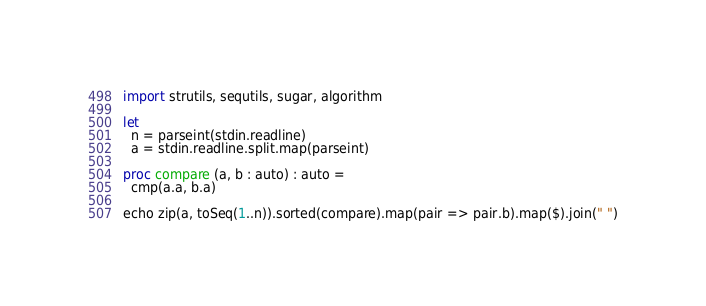Convert code to text. <code><loc_0><loc_0><loc_500><loc_500><_Nim_>import strutils, sequtils, sugar, algorithm

let
  n = parseint(stdin.readline)
  a = stdin.readline.split.map(parseint)

proc compare (a, b : auto) : auto =
  cmp(a.a, b.a)

echo zip(a, toSeq(1..n)).sorted(compare).map(pair => pair.b).map($).join(" ")
</code> 